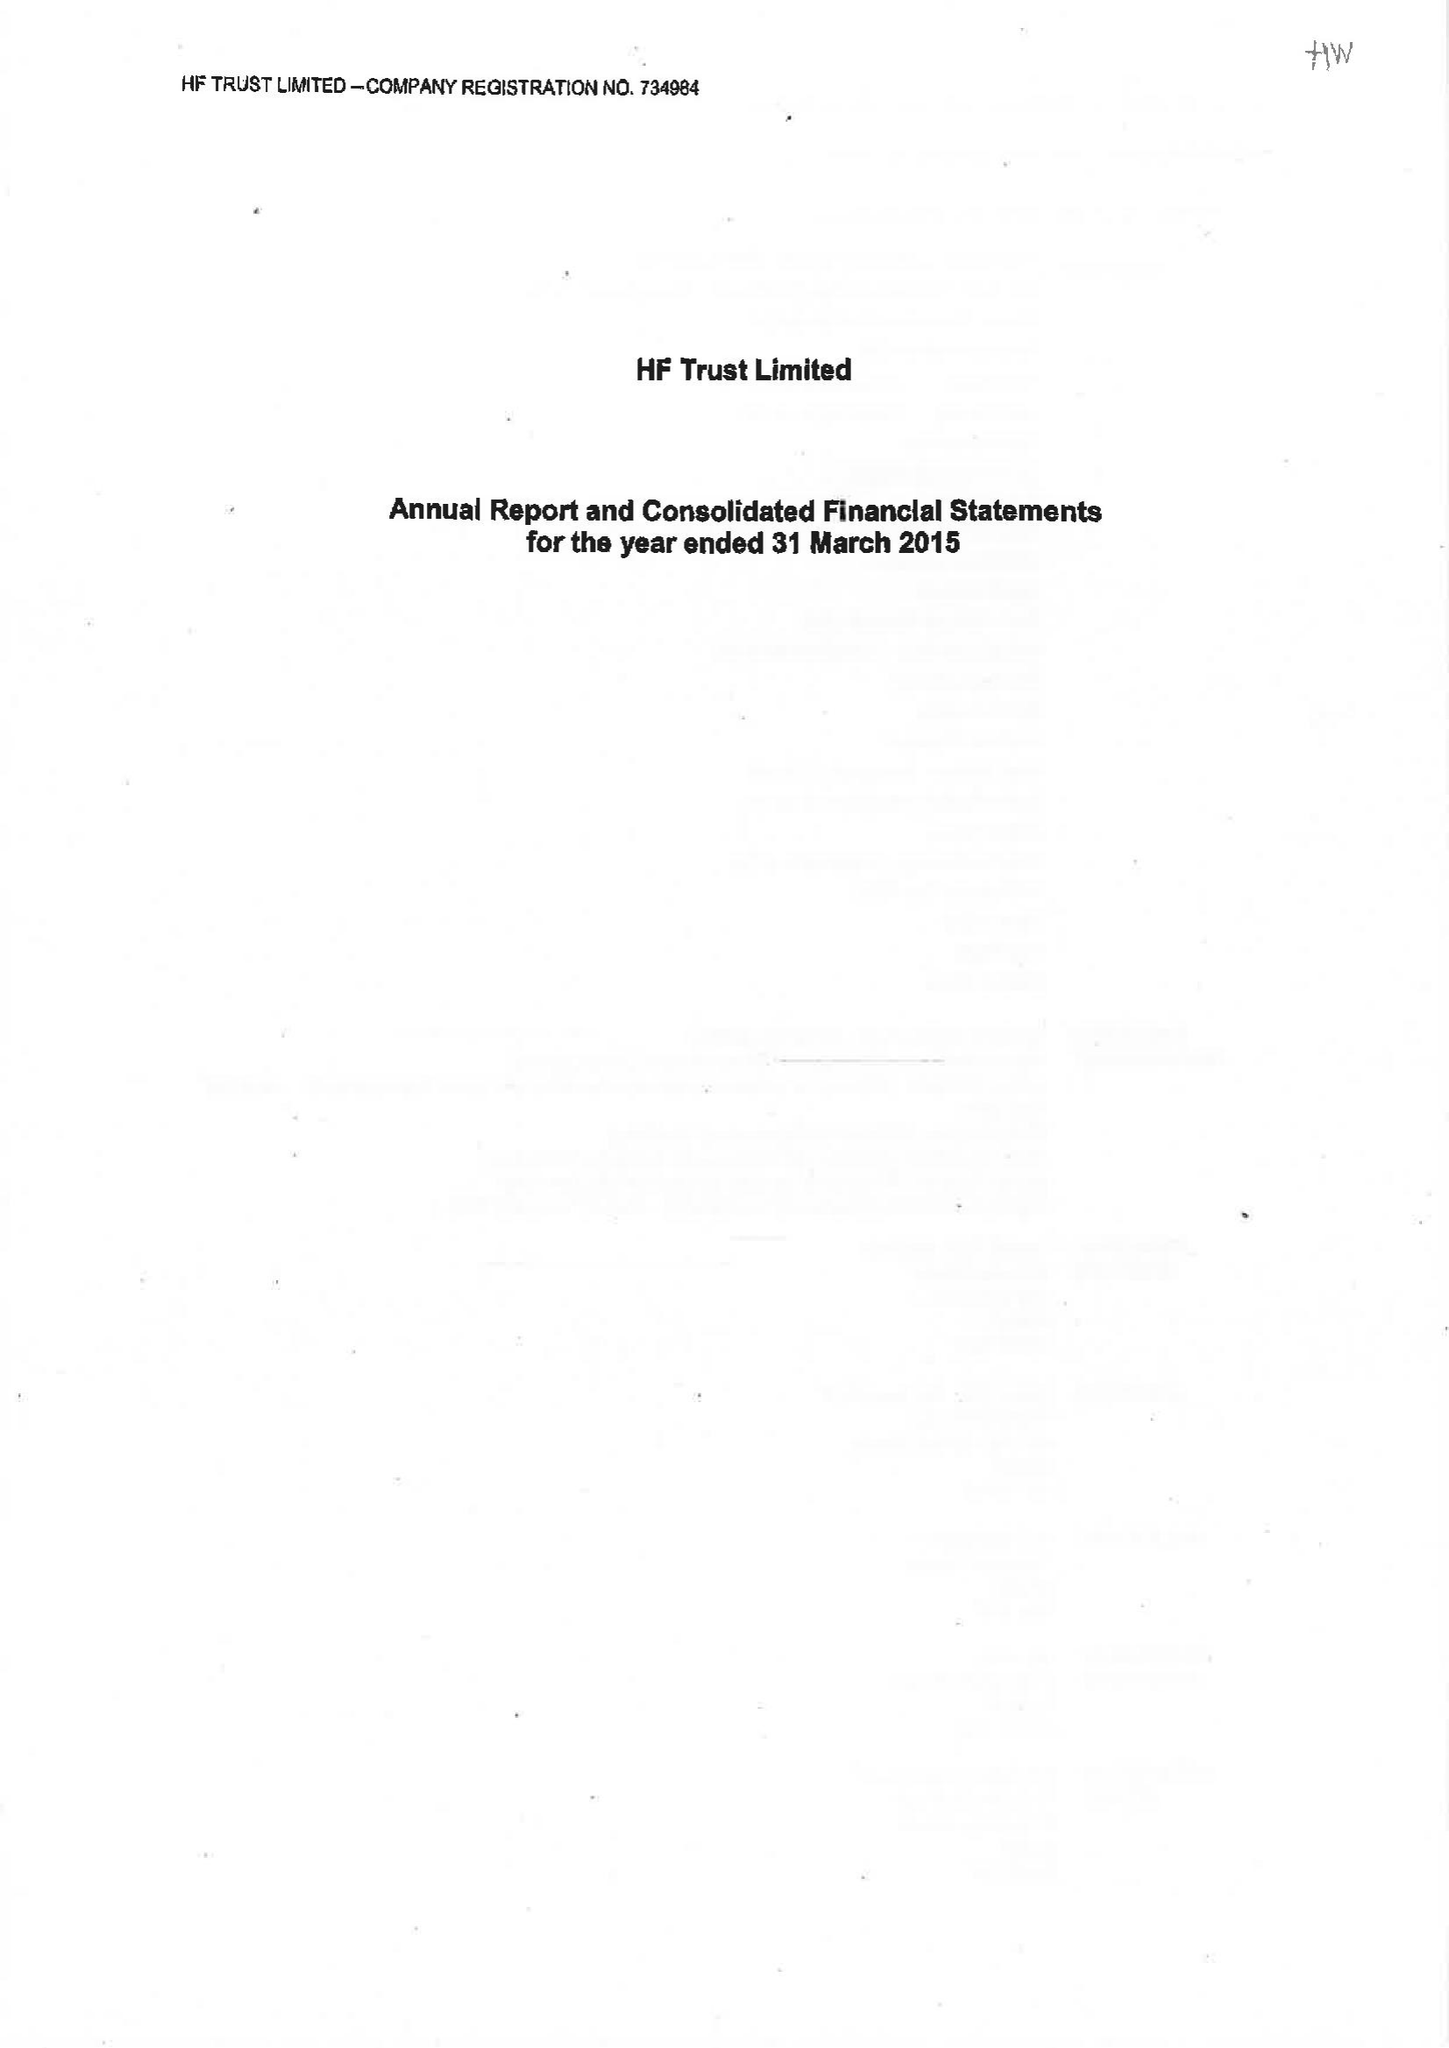What is the value for the address__street_line?
Answer the question using a single word or phrase. None 